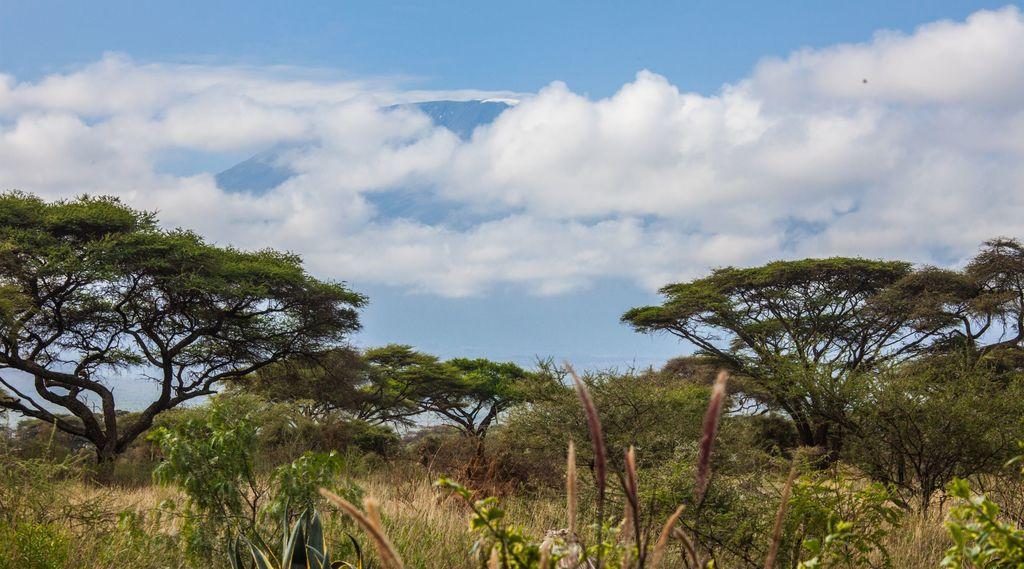Could you give a brief overview of what you see in this image? In this picture, we can see trees, plants, grass and the sky with clouds. 